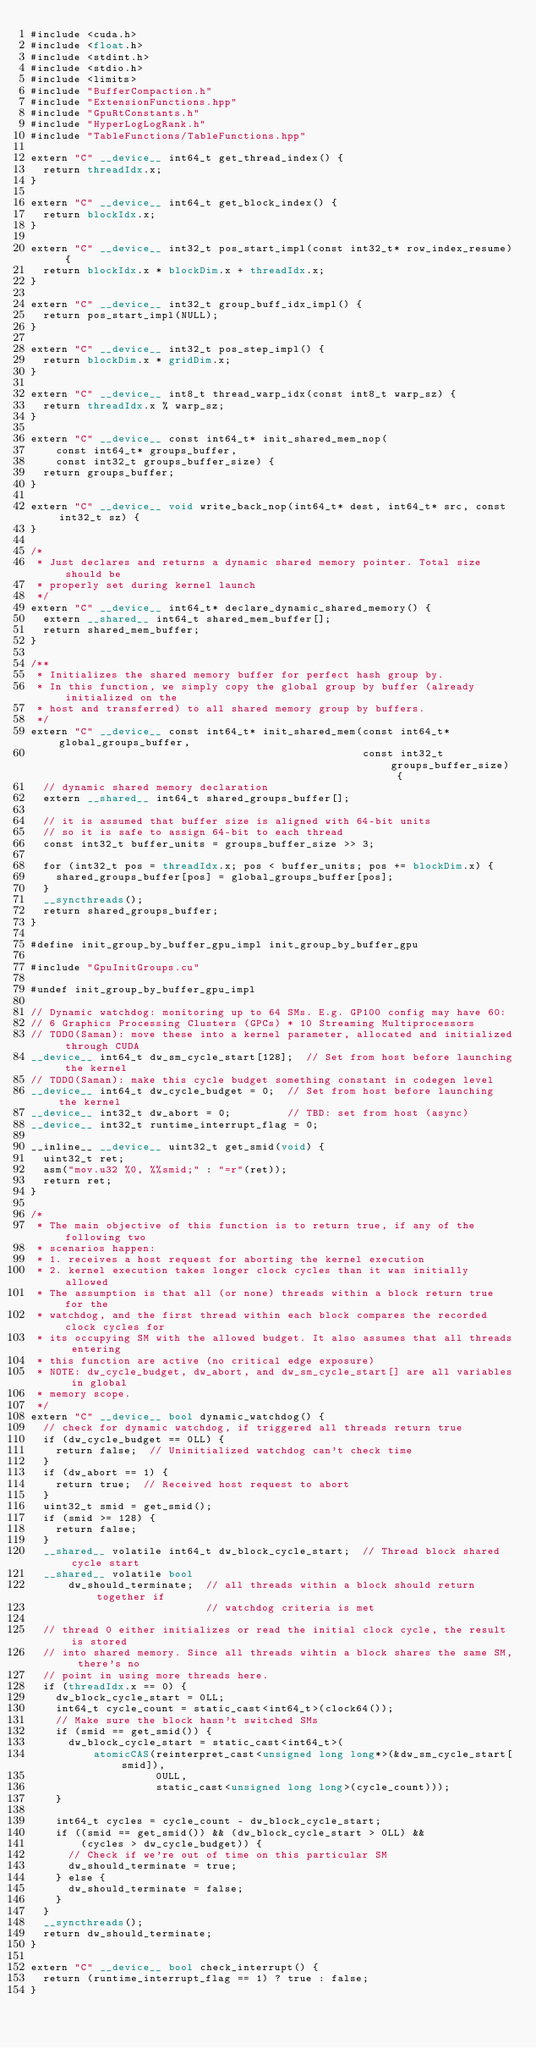Convert code to text. <code><loc_0><loc_0><loc_500><loc_500><_Cuda_>#include <cuda.h>
#include <float.h>
#include <stdint.h>
#include <stdio.h>
#include <limits>
#include "BufferCompaction.h"
#include "ExtensionFunctions.hpp"
#include "GpuRtConstants.h"
#include "HyperLogLogRank.h"
#include "TableFunctions/TableFunctions.hpp"

extern "C" __device__ int64_t get_thread_index() {
  return threadIdx.x;
}

extern "C" __device__ int64_t get_block_index() {
  return blockIdx.x;
}

extern "C" __device__ int32_t pos_start_impl(const int32_t* row_index_resume) {
  return blockIdx.x * blockDim.x + threadIdx.x;
}

extern "C" __device__ int32_t group_buff_idx_impl() {
  return pos_start_impl(NULL);
}

extern "C" __device__ int32_t pos_step_impl() {
  return blockDim.x * gridDim.x;
}

extern "C" __device__ int8_t thread_warp_idx(const int8_t warp_sz) {
  return threadIdx.x % warp_sz;
}

extern "C" __device__ const int64_t* init_shared_mem_nop(
    const int64_t* groups_buffer,
    const int32_t groups_buffer_size) {
  return groups_buffer;
}

extern "C" __device__ void write_back_nop(int64_t* dest, int64_t* src, const int32_t sz) {
}

/*
 * Just declares and returns a dynamic shared memory pointer. Total size should be
 * properly set during kernel launch
 */
extern "C" __device__ int64_t* declare_dynamic_shared_memory() {
  extern __shared__ int64_t shared_mem_buffer[];
  return shared_mem_buffer;
}

/**
 * Initializes the shared memory buffer for perfect hash group by.
 * In this function, we simply copy the global group by buffer (already initialized on the
 * host and transferred) to all shared memory group by buffers.
 */
extern "C" __device__ const int64_t* init_shared_mem(const int64_t* global_groups_buffer,
                                                     const int32_t groups_buffer_size) {
  // dynamic shared memory declaration
  extern __shared__ int64_t shared_groups_buffer[];

  // it is assumed that buffer size is aligned with 64-bit units
  // so it is safe to assign 64-bit to each thread
  const int32_t buffer_units = groups_buffer_size >> 3;

  for (int32_t pos = threadIdx.x; pos < buffer_units; pos += blockDim.x) {
    shared_groups_buffer[pos] = global_groups_buffer[pos];
  }
  __syncthreads();
  return shared_groups_buffer;
}

#define init_group_by_buffer_gpu_impl init_group_by_buffer_gpu

#include "GpuInitGroups.cu"

#undef init_group_by_buffer_gpu_impl

// Dynamic watchdog: monitoring up to 64 SMs. E.g. GP100 config may have 60:
// 6 Graphics Processing Clusters (GPCs) * 10 Streaming Multiprocessors
// TODO(Saman): move these into a kernel parameter, allocated and initialized through CUDA
__device__ int64_t dw_sm_cycle_start[128];  // Set from host before launching the kernel
// TODO(Saman): make this cycle budget something constant in codegen level
__device__ int64_t dw_cycle_budget = 0;  // Set from host before launching the kernel
__device__ int32_t dw_abort = 0;         // TBD: set from host (async)
__device__ int32_t runtime_interrupt_flag = 0;

__inline__ __device__ uint32_t get_smid(void) {
  uint32_t ret;
  asm("mov.u32 %0, %%smid;" : "=r"(ret));
  return ret;
}

/*
 * The main objective of this function is to return true, if any of the following two
 * scenarios happen:
 * 1. receives a host request for aborting the kernel execution
 * 2. kernel execution takes longer clock cycles than it was initially allowed
 * The assumption is that all (or none) threads within a block return true for the
 * watchdog, and the first thread within each block compares the recorded clock cycles for
 * its occupying SM with the allowed budget. It also assumes that all threads entering
 * this function are active (no critical edge exposure)
 * NOTE: dw_cycle_budget, dw_abort, and dw_sm_cycle_start[] are all variables in global
 * memory scope.
 */
extern "C" __device__ bool dynamic_watchdog() {
  // check for dynamic watchdog, if triggered all threads return true
  if (dw_cycle_budget == 0LL) {
    return false;  // Uninitialized watchdog can't check time
  }
  if (dw_abort == 1) {
    return true;  // Received host request to abort
  }
  uint32_t smid = get_smid();
  if (smid >= 128) {
    return false;
  }
  __shared__ volatile int64_t dw_block_cycle_start;  // Thread block shared cycle start
  __shared__ volatile bool
      dw_should_terminate;  // all threads within a block should return together if
                            // watchdog criteria is met

  // thread 0 either initializes or read the initial clock cycle, the result is stored
  // into shared memory. Since all threads wihtin a block shares the same SM, there's no
  // point in using more threads here.
  if (threadIdx.x == 0) {
    dw_block_cycle_start = 0LL;
    int64_t cycle_count = static_cast<int64_t>(clock64());
    // Make sure the block hasn't switched SMs
    if (smid == get_smid()) {
      dw_block_cycle_start = static_cast<int64_t>(
          atomicCAS(reinterpret_cast<unsigned long long*>(&dw_sm_cycle_start[smid]),
                    0ULL,
                    static_cast<unsigned long long>(cycle_count)));
    }

    int64_t cycles = cycle_count - dw_block_cycle_start;
    if ((smid == get_smid()) && (dw_block_cycle_start > 0LL) &&
        (cycles > dw_cycle_budget)) {
      // Check if we're out of time on this particular SM
      dw_should_terminate = true;
    } else {
      dw_should_terminate = false;
    }
  }
  __syncthreads();
  return dw_should_terminate;
}

extern "C" __device__ bool check_interrupt() {
  return (runtime_interrupt_flag == 1) ? true : false;
}
</code> 